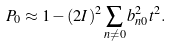Convert formula to latex. <formula><loc_0><loc_0><loc_500><loc_500>P _ { 0 } \approx 1 - ( 2 I ) ^ { 2 } \sum _ { n \ne 0 } b _ { n 0 } ^ { 2 } t ^ { 2 } .</formula> 